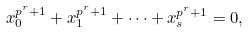Convert formula to latex. <formula><loc_0><loc_0><loc_500><loc_500>x _ { 0 } ^ { p ^ { r } + 1 } + x _ { 1 } ^ { p ^ { r } + 1 } + \cdots + x _ { s } ^ { p ^ { r } + 1 } = 0 ,</formula> 